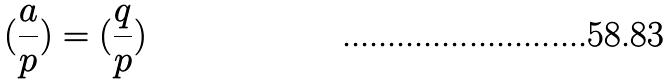<formula> <loc_0><loc_0><loc_500><loc_500>( \frac { a } { p } ) = ( \frac { q } { p } )</formula> 